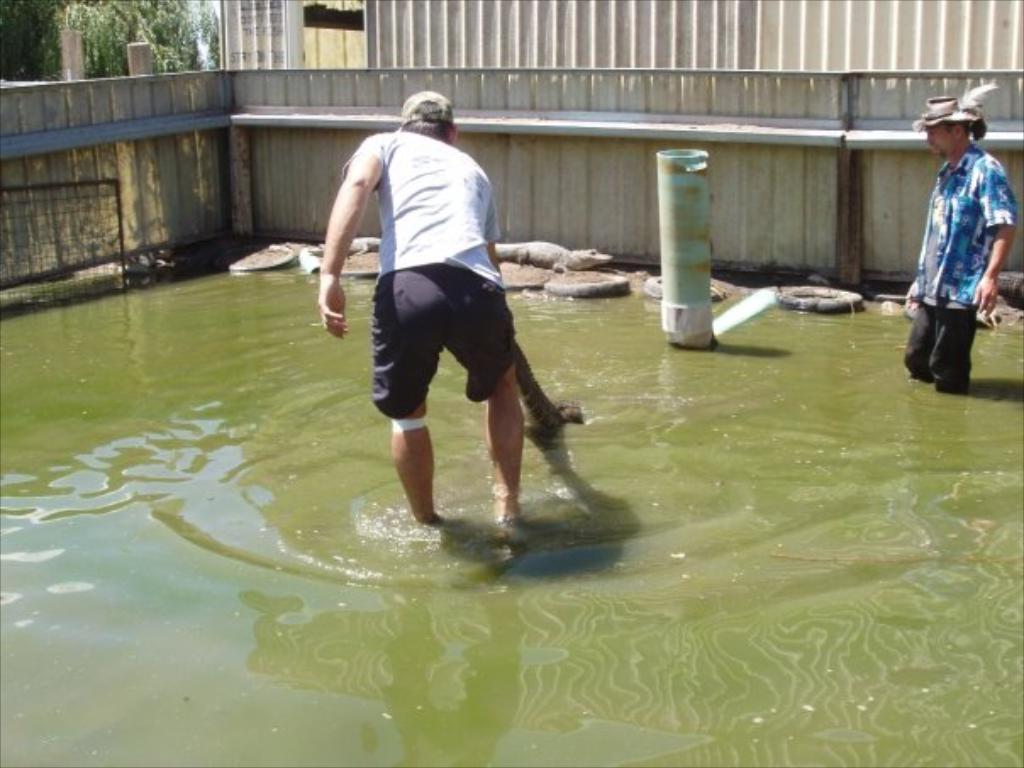Please provide a concise description of this image. In the foreground I can see a person is holding a reptile in hand and one person is standing in the water. In the background I can see fence, crocodiles, some objects, building and trees. This image is taken may be during a day. 